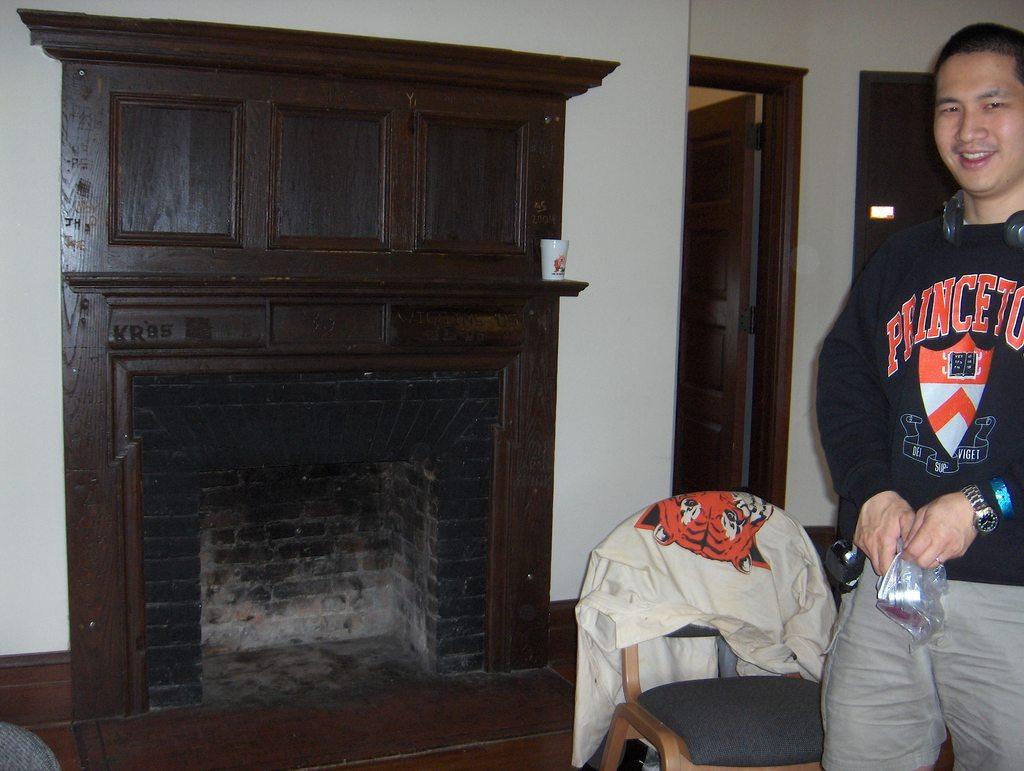What is the college name on his sweater ?
Ensure brevity in your answer.  Princeton. Is he logo on the shirt a tiger?
Your response must be concise. Yes. 